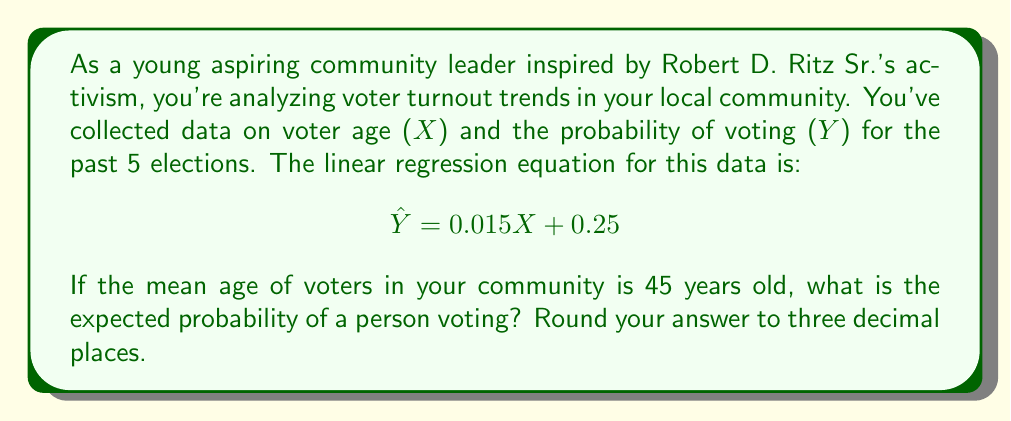What is the answer to this math problem? To solve this problem, we'll use the given linear regression equation and the mean age of voters in the community. Here's a step-by-step explanation:

1. The linear regression equation is given as:
   $$ \hat{Y} = 0.015X + 0.25 $$
   Where $\hat{Y}$ is the predicted probability of voting, and $X$ is the age of the voter.

2. We're told that the mean age of voters in the community is 45 years old. We'll substitute this value for $X$ in our equation:
   $$ \hat{Y} = 0.015(45) + 0.25 $$

3. Now, let's solve the equation:
   $$ \hat{Y} = 0.675 + 0.25 $$
   $$ \hat{Y} = 0.925 $$

4. Rounding to three decimal places:
   $$ \hat{Y} \approx 0.925 $$

This result indicates that for a person of average age (45 years old) in your community, the expected probability of voting is 0.925 or 92.5%.
Answer: 0.925 